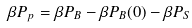<formula> <loc_0><loc_0><loc_500><loc_500>\beta P _ { p } = \beta P _ { B } - \beta P _ { B } ( 0 ) - \beta P _ { S }</formula> 